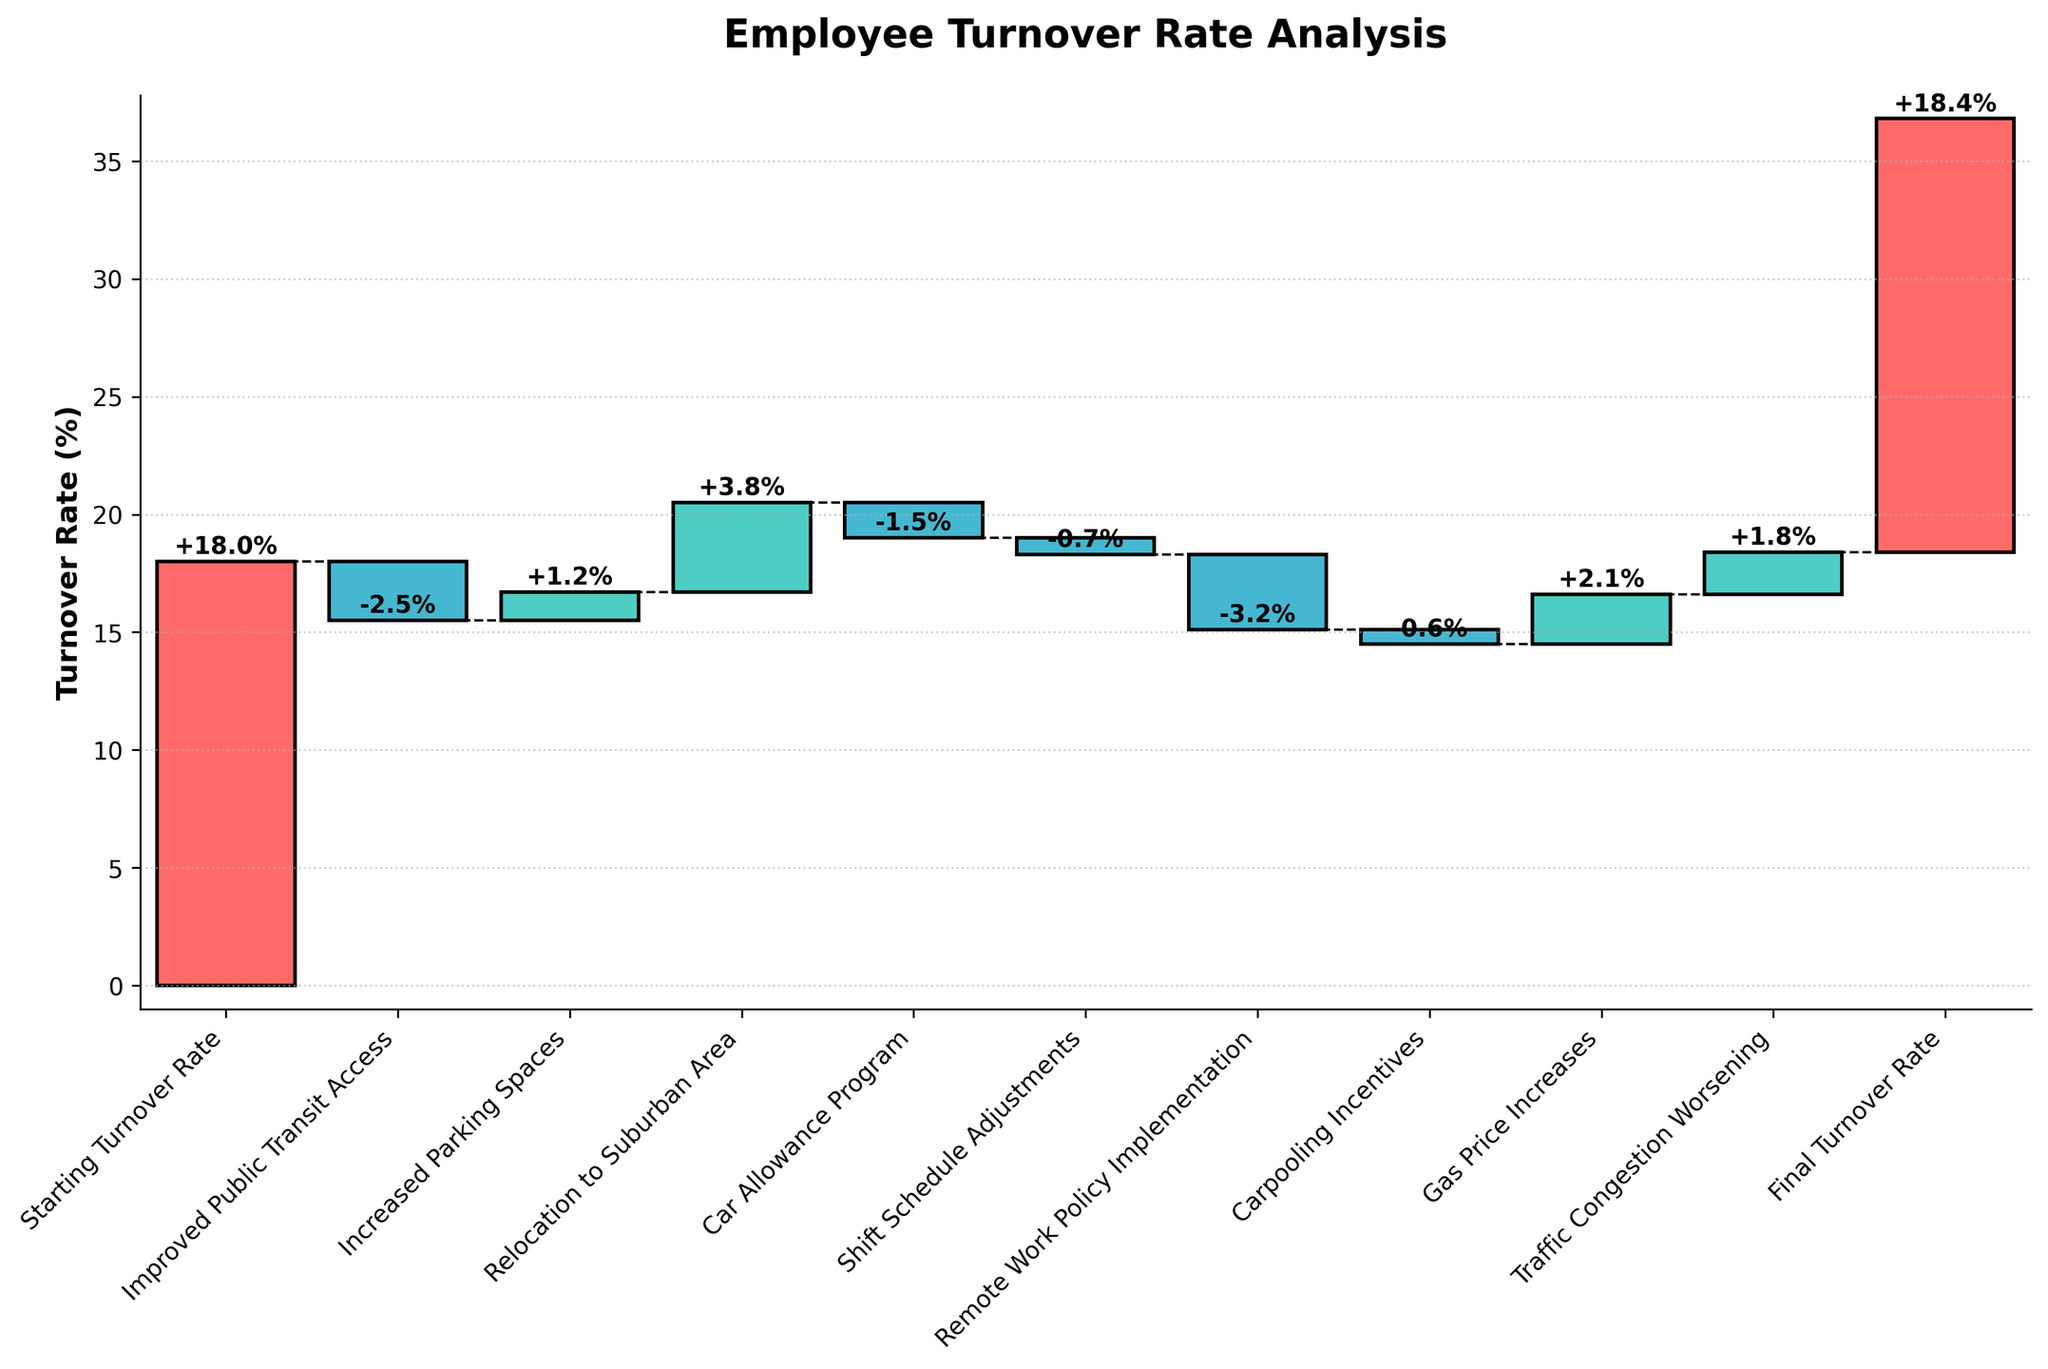How many categories are listed in the chart? Count the number of different categories listed on the X-axis.
Answer: 10 What is the overall effect of remote work policy implementation on the turnover rate? Identify the value associated with "Remote Work Policy Implementation".
Answer: -3.2% What is the difference in turnover rate before and after traffic congestion worsening? Compare the turnover rate value before "Traffic Congestion Worsening" with the value after. First, find the rate just before, then the rate after adding the effect of traffic congestion. Calculate the difference.
Answer: +1.8% Which action had the most significant negative impact on turnover rate? Look for the category with the most negative value.
Answer: Remote Work Policy Implementation (-3.2%) How did relocation to the suburban area affect the turnover rate? Identify the value associated with "Relocation to Suburban Area".
Answer: +3.8% What is the range of turnover rate values across all categories? Identify the minimum and maximum values listed for the categories, and subtract the minimum from the maximum.
Answer: 6.3% How did improved public transit access influence the turnover rate compared to increased parking spaces? Find the values for "Improved Public Transit Access" and "Increased Parking Spaces" and compare them.
Answer: -2.5% vs +1.2% What is the final turnover rate after considering all the interventions? Refer to the value listed under "Final Turnover Rate".
Answer: 18.4% By how much did the gas price increases affect the turnover rate? Identify the value associated with "Gas Price Increases".
Answer: +2.1% What is the net change in the turnover rate from the starting value to the final value? Calculate the difference between the "Final Turnover Rate" and the "Starting Turnover Rate".
Answer: +0.4% 